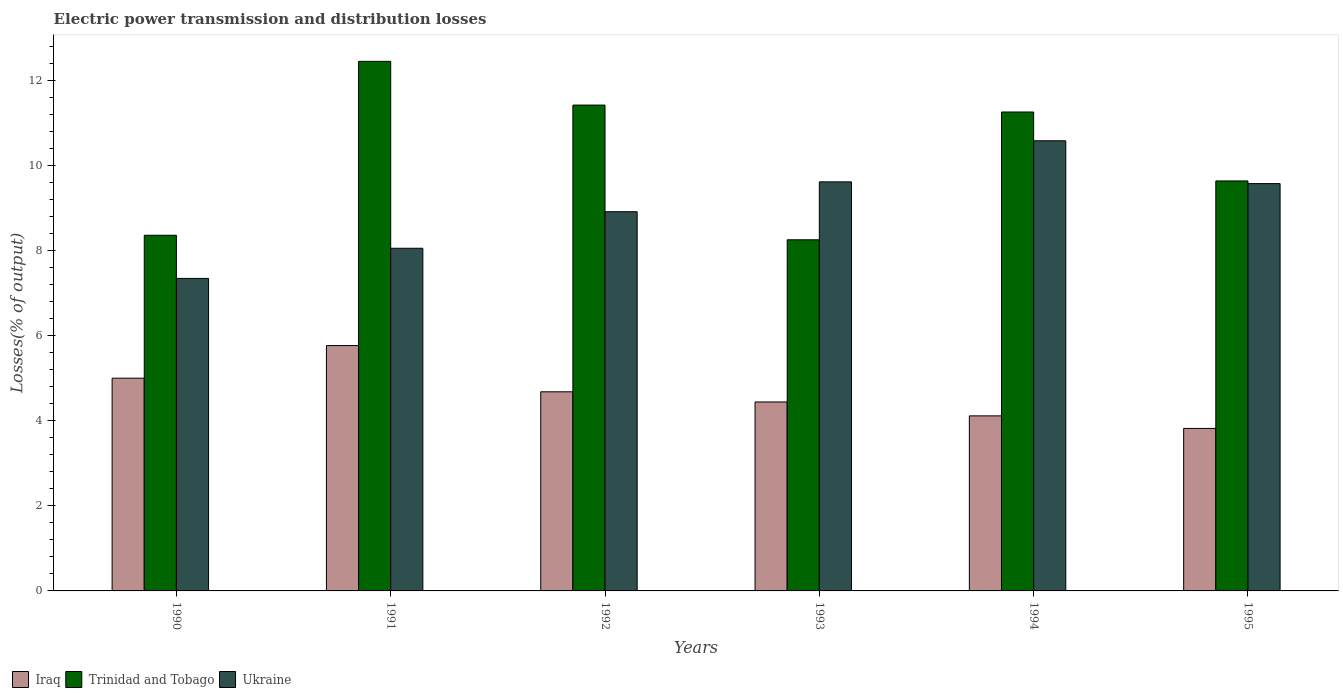How many different coloured bars are there?
Offer a terse response. 3. How many groups of bars are there?
Your response must be concise. 6. Are the number of bars per tick equal to the number of legend labels?
Ensure brevity in your answer.  Yes. How many bars are there on the 5th tick from the left?
Your answer should be very brief. 3. What is the label of the 5th group of bars from the left?
Give a very brief answer. 1994. In how many cases, is the number of bars for a given year not equal to the number of legend labels?
Offer a very short reply. 0. What is the electric power transmission and distribution losses in Ukraine in 1994?
Keep it short and to the point. 10.58. Across all years, what is the maximum electric power transmission and distribution losses in Ukraine?
Give a very brief answer. 10.58. Across all years, what is the minimum electric power transmission and distribution losses in Trinidad and Tobago?
Offer a terse response. 8.25. What is the total electric power transmission and distribution losses in Trinidad and Tobago in the graph?
Offer a very short reply. 61.37. What is the difference between the electric power transmission and distribution losses in Iraq in 1991 and that in 1993?
Make the answer very short. 1.33. What is the difference between the electric power transmission and distribution losses in Iraq in 1995 and the electric power transmission and distribution losses in Ukraine in 1990?
Provide a succinct answer. -3.52. What is the average electric power transmission and distribution losses in Trinidad and Tobago per year?
Offer a terse response. 10.23. In the year 1995, what is the difference between the electric power transmission and distribution losses in Iraq and electric power transmission and distribution losses in Trinidad and Tobago?
Offer a terse response. -5.82. What is the ratio of the electric power transmission and distribution losses in Trinidad and Tobago in 1991 to that in 1995?
Offer a terse response. 1.29. Is the electric power transmission and distribution losses in Iraq in 1994 less than that in 1995?
Provide a succinct answer. No. What is the difference between the highest and the second highest electric power transmission and distribution losses in Iraq?
Offer a terse response. 0.77. What is the difference between the highest and the lowest electric power transmission and distribution losses in Trinidad and Tobago?
Your answer should be very brief. 4.19. In how many years, is the electric power transmission and distribution losses in Trinidad and Tobago greater than the average electric power transmission and distribution losses in Trinidad and Tobago taken over all years?
Keep it short and to the point. 3. What does the 3rd bar from the left in 1993 represents?
Make the answer very short. Ukraine. What does the 3rd bar from the right in 1990 represents?
Provide a succinct answer. Iraq. Are all the bars in the graph horizontal?
Your response must be concise. No. Does the graph contain any zero values?
Give a very brief answer. No. Where does the legend appear in the graph?
Give a very brief answer. Bottom left. What is the title of the graph?
Offer a terse response. Electric power transmission and distribution losses. What is the label or title of the X-axis?
Give a very brief answer. Years. What is the label or title of the Y-axis?
Your answer should be compact. Losses(% of output). What is the Losses(% of output) of Iraq in 1990?
Provide a succinct answer. 5. What is the Losses(% of output) in Trinidad and Tobago in 1990?
Your response must be concise. 8.36. What is the Losses(% of output) in Ukraine in 1990?
Offer a terse response. 7.34. What is the Losses(% of output) in Iraq in 1991?
Keep it short and to the point. 5.77. What is the Losses(% of output) of Trinidad and Tobago in 1991?
Your answer should be compact. 12.45. What is the Losses(% of output) in Ukraine in 1991?
Keep it short and to the point. 8.05. What is the Losses(% of output) in Iraq in 1992?
Provide a succinct answer. 4.68. What is the Losses(% of output) of Trinidad and Tobago in 1992?
Ensure brevity in your answer.  11.42. What is the Losses(% of output) in Ukraine in 1992?
Your answer should be very brief. 8.91. What is the Losses(% of output) in Iraq in 1993?
Keep it short and to the point. 4.44. What is the Losses(% of output) of Trinidad and Tobago in 1993?
Make the answer very short. 8.25. What is the Losses(% of output) of Ukraine in 1993?
Your answer should be compact. 9.61. What is the Losses(% of output) of Iraq in 1994?
Make the answer very short. 4.11. What is the Losses(% of output) in Trinidad and Tobago in 1994?
Provide a succinct answer. 11.26. What is the Losses(% of output) in Ukraine in 1994?
Ensure brevity in your answer.  10.58. What is the Losses(% of output) of Iraq in 1995?
Offer a terse response. 3.82. What is the Losses(% of output) of Trinidad and Tobago in 1995?
Offer a very short reply. 9.64. What is the Losses(% of output) of Ukraine in 1995?
Your answer should be very brief. 9.57. Across all years, what is the maximum Losses(% of output) in Iraq?
Give a very brief answer. 5.77. Across all years, what is the maximum Losses(% of output) in Trinidad and Tobago?
Your answer should be very brief. 12.45. Across all years, what is the maximum Losses(% of output) in Ukraine?
Keep it short and to the point. 10.58. Across all years, what is the minimum Losses(% of output) in Iraq?
Ensure brevity in your answer.  3.82. Across all years, what is the minimum Losses(% of output) of Trinidad and Tobago?
Ensure brevity in your answer.  8.25. Across all years, what is the minimum Losses(% of output) in Ukraine?
Your response must be concise. 7.34. What is the total Losses(% of output) of Iraq in the graph?
Give a very brief answer. 27.82. What is the total Losses(% of output) of Trinidad and Tobago in the graph?
Ensure brevity in your answer.  61.37. What is the total Losses(% of output) in Ukraine in the graph?
Offer a terse response. 54.08. What is the difference between the Losses(% of output) in Iraq in 1990 and that in 1991?
Offer a terse response. -0.77. What is the difference between the Losses(% of output) of Trinidad and Tobago in 1990 and that in 1991?
Offer a very short reply. -4.09. What is the difference between the Losses(% of output) in Ukraine in 1990 and that in 1991?
Your answer should be compact. -0.71. What is the difference between the Losses(% of output) of Iraq in 1990 and that in 1992?
Your answer should be compact. 0.32. What is the difference between the Losses(% of output) in Trinidad and Tobago in 1990 and that in 1992?
Make the answer very short. -3.06. What is the difference between the Losses(% of output) in Ukraine in 1990 and that in 1992?
Your answer should be very brief. -1.57. What is the difference between the Losses(% of output) in Iraq in 1990 and that in 1993?
Keep it short and to the point. 0.56. What is the difference between the Losses(% of output) of Trinidad and Tobago in 1990 and that in 1993?
Make the answer very short. 0.11. What is the difference between the Losses(% of output) in Ukraine in 1990 and that in 1993?
Your response must be concise. -2.27. What is the difference between the Losses(% of output) in Iraq in 1990 and that in 1994?
Your answer should be very brief. 0.89. What is the difference between the Losses(% of output) of Trinidad and Tobago in 1990 and that in 1994?
Your answer should be very brief. -2.9. What is the difference between the Losses(% of output) of Ukraine in 1990 and that in 1994?
Make the answer very short. -3.24. What is the difference between the Losses(% of output) in Iraq in 1990 and that in 1995?
Make the answer very short. 1.18. What is the difference between the Losses(% of output) of Trinidad and Tobago in 1990 and that in 1995?
Make the answer very short. -1.28. What is the difference between the Losses(% of output) of Ukraine in 1990 and that in 1995?
Offer a very short reply. -2.23. What is the difference between the Losses(% of output) in Iraq in 1991 and that in 1992?
Offer a very short reply. 1.09. What is the difference between the Losses(% of output) of Trinidad and Tobago in 1991 and that in 1992?
Offer a terse response. 1.03. What is the difference between the Losses(% of output) in Ukraine in 1991 and that in 1992?
Keep it short and to the point. -0.86. What is the difference between the Losses(% of output) in Iraq in 1991 and that in 1993?
Provide a short and direct response. 1.33. What is the difference between the Losses(% of output) in Trinidad and Tobago in 1991 and that in 1993?
Keep it short and to the point. 4.19. What is the difference between the Losses(% of output) in Ukraine in 1991 and that in 1993?
Provide a succinct answer. -1.56. What is the difference between the Losses(% of output) of Iraq in 1991 and that in 1994?
Your answer should be very brief. 1.65. What is the difference between the Losses(% of output) in Trinidad and Tobago in 1991 and that in 1994?
Provide a succinct answer. 1.19. What is the difference between the Losses(% of output) of Ukraine in 1991 and that in 1994?
Ensure brevity in your answer.  -2.53. What is the difference between the Losses(% of output) of Iraq in 1991 and that in 1995?
Offer a terse response. 1.95. What is the difference between the Losses(% of output) of Trinidad and Tobago in 1991 and that in 1995?
Offer a terse response. 2.81. What is the difference between the Losses(% of output) of Ukraine in 1991 and that in 1995?
Make the answer very short. -1.52. What is the difference between the Losses(% of output) in Iraq in 1992 and that in 1993?
Give a very brief answer. 0.24. What is the difference between the Losses(% of output) of Trinidad and Tobago in 1992 and that in 1993?
Provide a short and direct response. 3.17. What is the difference between the Losses(% of output) in Ukraine in 1992 and that in 1993?
Give a very brief answer. -0.7. What is the difference between the Losses(% of output) of Iraq in 1992 and that in 1994?
Keep it short and to the point. 0.57. What is the difference between the Losses(% of output) of Trinidad and Tobago in 1992 and that in 1994?
Offer a very short reply. 0.16. What is the difference between the Losses(% of output) in Ukraine in 1992 and that in 1994?
Offer a very short reply. -1.67. What is the difference between the Losses(% of output) in Iraq in 1992 and that in 1995?
Keep it short and to the point. 0.86. What is the difference between the Losses(% of output) in Trinidad and Tobago in 1992 and that in 1995?
Ensure brevity in your answer.  1.78. What is the difference between the Losses(% of output) in Ukraine in 1992 and that in 1995?
Offer a terse response. -0.66. What is the difference between the Losses(% of output) in Iraq in 1993 and that in 1994?
Your answer should be very brief. 0.33. What is the difference between the Losses(% of output) of Trinidad and Tobago in 1993 and that in 1994?
Offer a terse response. -3. What is the difference between the Losses(% of output) of Ukraine in 1993 and that in 1994?
Make the answer very short. -0.97. What is the difference between the Losses(% of output) of Iraq in 1993 and that in 1995?
Make the answer very short. 0.62. What is the difference between the Losses(% of output) in Trinidad and Tobago in 1993 and that in 1995?
Offer a terse response. -1.38. What is the difference between the Losses(% of output) in Ukraine in 1993 and that in 1995?
Offer a very short reply. 0.04. What is the difference between the Losses(% of output) in Iraq in 1994 and that in 1995?
Your response must be concise. 0.29. What is the difference between the Losses(% of output) in Trinidad and Tobago in 1994 and that in 1995?
Your answer should be compact. 1.62. What is the difference between the Losses(% of output) in Iraq in 1990 and the Losses(% of output) in Trinidad and Tobago in 1991?
Your answer should be very brief. -7.45. What is the difference between the Losses(% of output) in Iraq in 1990 and the Losses(% of output) in Ukraine in 1991?
Your answer should be compact. -3.05. What is the difference between the Losses(% of output) of Trinidad and Tobago in 1990 and the Losses(% of output) of Ukraine in 1991?
Offer a very short reply. 0.31. What is the difference between the Losses(% of output) of Iraq in 1990 and the Losses(% of output) of Trinidad and Tobago in 1992?
Offer a terse response. -6.42. What is the difference between the Losses(% of output) of Iraq in 1990 and the Losses(% of output) of Ukraine in 1992?
Offer a terse response. -3.91. What is the difference between the Losses(% of output) of Trinidad and Tobago in 1990 and the Losses(% of output) of Ukraine in 1992?
Make the answer very short. -0.55. What is the difference between the Losses(% of output) of Iraq in 1990 and the Losses(% of output) of Trinidad and Tobago in 1993?
Your response must be concise. -3.25. What is the difference between the Losses(% of output) of Iraq in 1990 and the Losses(% of output) of Ukraine in 1993?
Provide a short and direct response. -4.61. What is the difference between the Losses(% of output) of Trinidad and Tobago in 1990 and the Losses(% of output) of Ukraine in 1993?
Offer a terse response. -1.25. What is the difference between the Losses(% of output) in Iraq in 1990 and the Losses(% of output) in Trinidad and Tobago in 1994?
Your answer should be compact. -6.26. What is the difference between the Losses(% of output) in Iraq in 1990 and the Losses(% of output) in Ukraine in 1994?
Offer a very short reply. -5.58. What is the difference between the Losses(% of output) in Trinidad and Tobago in 1990 and the Losses(% of output) in Ukraine in 1994?
Your answer should be compact. -2.22. What is the difference between the Losses(% of output) in Iraq in 1990 and the Losses(% of output) in Trinidad and Tobago in 1995?
Give a very brief answer. -4.64. What is the difference between the Losses(% of output) in Iraq in 1990 and the Losses(% of output) in Ukraine in 1995?
Make the answer very short. -4.57. What is the difference between the Losses(% of output) of Trinidad and Tobago in 1990 and the Losses(% of output) of Ukraine in 1995?
Offer a terse response. -1.21. What is the difference between the Losses(% of output) in Iraq in 1991 and the Losses(% of output) in Trinidad and Tobago in 1992?
Make the answer very short. -5.65. What is the difference between the Losses(% of output) in Iraq in 1991 and the Losses(% of output) in Ukraine in 1992?
Give a very brief answer. -3.15. What is the difference between the Losses(% of output) in Trinidad and Tobago in 1991 and the Losses(% of output) in Ukraine in 1992?
Keep it short and to the point. 3.53. What is the difference between the Losses(% of output) in Iraq in 1991 and the Losses(% of output) in Trinidad and Tobago in 1993?
Provide a short and direct response. -2.49. What is the difference between the Losses(% of output) of Iraq in 1991 and the Losses(% of output) of Ukraine in 1993?
Offer a very short reply. -3.85. What is the difference between the Losses(% of output) of Trinidad and Tobago in 1991 and the Losses(% of output) of Ukraine in 1993?
Ensure brevity in your answer.  2.83. What is the difference between the Losses(% of output) in Iraq in 1991 and the Losses(% of output) in Trinidad and Tobago in 1994?
Ensure brevity in your answer.  -5.49. What is the difference between the Losses(% of output) in Iraq in 1991 and the Losses(% of output) in Ukraine in 1994?
Your response must be concise. -4.81. What is the difference between the Losses(% of output) of Trinidad and Tobago in 1991 and the Losses(% of output) of Ukraine in 1994?
Keep it short and to the point. 1.87. What is the difference between the Losses(% of output) in Iraq in 1991 and the Losses(% of output) in Trinidad and Tobago in 1995?
Give a very brief answer. -3.87. What is the difference between the Losses(% of output) of Iraq in 1991 and the Losses(% of output) of Ukraine in 1995?
Ensure brevity in your answer.  -3.81. What is the difference between the Losses(% of output) of Trinidad and Tobago in 1991 and the Losses(% of output) of Ukraine in 1995?
Make the answer very short. 2.87. What is the difference between the Losses(% of output) of Iraq in 1992 and the Losses(% of output) of Trinidad and Tobago in 1993?
Keep it short and to the point. -3.57. What is the difference between the Losses(% of output) of Iraq in 1992 and the Losses(% of output) of Ukraine in 1993?
Give a very brief answer. -4.93. What is the difference between the Losses(% of output) of Trinidad and Tobago in 1992 and the Losses(% of output) of Ukraine in 1993?
Ensure brevity in your answer.  1.8. What is the difference between the Losses(% of output) of Iraq in 1992 and the Losses(% of output) of Trinidad and Tobago in 1994?
Your answer should be very brief. -6.58. What is the difference between the Losses(% of output) of Iraq in 1992 and the Losses(% of output) of Ukraine in 1994?
Your answer should be compact. -5.9. What is the difference between the Losses(% of output) of Trinidad and Tobago in 1992 and the Losses(% of output) of Ukraine in 1994?
Keep it short and to the point. 0.84. What is the difference between the Losses(% of output) in Iraq in 1992 and the Losses(% of output) in Trinidad and Tobago in 1995?
Provide a succinct answer. -4.96. What is the difference between the Losses(% of output) in Iraq in 1992 and the Losses(% of output) in Ukraine in 1995?
Offer a very short reply. -4.89. What is the difference between the Losses(% of output) of Trinidad and Tobago in 1992 and the Losses(% of output) of Ukraine in 1995?
Your answer should be compact. 1.85. What is the difference between the Losses(% of output) of Iraq in 1993 and the Losses(% of output) of Trinidad and Tobago in 1994?
Your answer should be very brief. -6.81. What is the difference between the Losses(% of output) of Iraq in 1993 and the Losses(% of output) of Ukraine in 1994?
Offer a very short reply. -6.14. What is the difference between the Losses(% of output) in Trinidad and Tobago in 1993 and the Losses(% of output) in Ukraine in 1994?
Keep it short and to the point. -2.33. What is the difference between the Losses(% of output) of Iraq in 1993 and the Losses(% of output) of Trinidad and Tobago in 1995?
Your response must be concise. -5.19. What is the difference between the Losses(% of output) in Iraq in 1993 and the Losses(% of output) in Ukraine in 1995?
Give a very brief answer. -5.13. What is the difference between the Losses(% of output) of Trinidad and Tobago in 1993 and the Losses(% of output) of Ukraine in 1995?
Your response must be concise. -1.32. What is the difference between the Losses(% of output) in Iraq in 1994 and the Losses(% of output) in Trinidad and Tobago in 1995?
Offer a terse response. -5.52. What is the difference between the Losses(% of output) of Iraq in 1994 and the Losses(% of output) of Ukraine in 1995?
Provide a succinct answer. -5.46. What is the difference between the Losses(% of output) in Trinidad and Tobago in 1994 and the Losses(% of output) in Ukraine in 1995?
Make the answer very short. 1.68. What is the average Losses(% of output) of Iraq per year?
Provide a short and direct response. 4.64. What is the average Losses(% of output) in Trinidad and Tobago per year?
Offer a terse response. 10.23. What is the average Losses(% of output) of Ukraine per year?
Give a very brief answer. 9.01. In the year 1990, what is the difference between the Losses(% of output) of Iraq and Losses(% of output) of Trinidad and Tobago?
Give a very brief answer. -3.36. In the year 1990, what is the difference between the Losses(% of output) in Iraq and Losses(% of output) in Ukraine?
Your answer should be compact. -2.34. In the year 1990, what is the difference between the Losses(% of output) of Trinidad and Tobago and Losses(% of output) of Ukraine?
Offer a terse response. 1.01. In the year 1991, what is the difference between the Losses(% of output) in Iraq and Losses(% of output) in Trinidad and Tobago?
Your answer should be very brief. -6.68. In the year 1991, what is the difference between the Losses(% of output) of Iraq and Losses(% of output) of Ukraine?
Give a very brief answer. -2.29. In the year 1991, what is the difference between the Losses(% of output) in Trinidad and Tobago and Losses(% of output) in Ukraine?
Make the answer very short. 4.39. In the year 1992, what is the difference between the Losses(% of output) in Iraq and Losses(% of output) in Trinidad and Tobago?
Provide a short and direct response. -6.74. In the year 1992, what is the difference between the Losses(% of output) of Iraq and Losses(% of output) of Ukraine?
Provide a succinct answer. -4.23. In the year 1992, what is the difference between the Losses(% of output) of Trinidad and Tobago and Losses(% of output) of Ukraine?
Your answer should be very brief. 2.51. In the year 1993, what is the difference between the Losses(% of output) in Iraq and Losses(% of output) in Trinidad and Tobago?
Your answer should be compact. -3.81. In the year 1993, what is the difference between the Losses(% of output) in Iraq and Losses(% of output) in Ukraine?
Keep it short and to the point. -5.17. In the year 1993, what is the difference between the Losses(% of output) of Trinidad and Tobago and Losses(% of output) of Ukraine?
Ensure brevity in your answer.  -1.36. In the year 1994, what is the difference between the Losses(% of output) of Iraq and Losses(% of output) of Trinidad and Tobago?
Make the answer very short. -7.14. In the year 1994, what is the difference between the Losses(% of output) of Iraq and Losses(% of output) of Ukraine?
Offer a terse response. -6.47. In the year 1994, what is the difference between the Losses(% of output) in Trinidad and Tobago and Losses(% of output) in Ukraine?
Your answer should be very brief. 0.68. In the year 1995, what is the difference between the Losses(% of output) of Iraq and Losses(% of output) of Trinidad and Tobago?
Your response must be concise. -5.82. In the year 1995, what is the difference between the Losses(% of output) of Iraq and Losses(% of output) of Ukraine?
Ensure brevity in your answer.  -5.75. In the year 1995, what is the difference between the Losses(% of output) in Trinidad and Tobago and Losses(% of output) in Ukraine?
Provide a short and direct response. 0.06. What is the ratio of the Losses(% of output) of Iraq in 1990 to that in 1991?
Offer a terse response. 0.87. What is the ratio of the Losses(% of output) in Trinidad and Tobago in 1990 to that in 1991?
Give a very brief answer. 0.67. What is the ratio of the Losses(% of output) in Ukraine in 1990 to that in 1991?
Your response must be concise. 0.91. What is the ratio of the Losses(% of output) of Iraq in 1990 to that in 1992?
Give a very brief answer. 1.07. What is the ratio of the Losses(% of output) in Trinidad and Tobago in 1990 to that in 1992?
Provide a succinct answer. 0.73. What is the ratio of the Losses(% of output) in Ukraine in 1990 to that in 1992?
Ensure brevity in your answer.  0.82. What is the ratio of the Losses(% of output) of Iraq in 1990 to that in 1993?
Offer a very short reply. 1.13. What is the ratio of the Losses(% of output) of Trinidad and Tobago in 1990 to that in 1993?
Provide a succinct answer. 1.01. What is the ratio of the Losses(% of output) of Ukraine in 1990 to that in 1993?
Your answer should be compact. 0.76. What is the ratio of the Losses(% of output) of Iraq in 1990 to that in 1994?
Ensure brevity in your answer.  1.22. What is the ratio of the Losses(% of output) of Trinidad and Tobago in 1990 to that in 1994?
Offer a terse response. 0.74. What is the ratio of the Losses(% of output) in Ukraine in 1990 to that in 1994?
Provide a succinct answer. 0.69. What is the ratio of the Losses(% of output) in Iraq in 1990 to that in 1995?
Make the answer very short. 1.31. What is the ratio of the Losses(% of output) of Trinidad and Tobago in 1990 to that in 1995?
Your response must be concise. 0.87. What is the ratio of the Losses(% of output) of Ukraine in 1990 to that in 1995?
Keep it short and to the point. 0.77. What is the ratio of the Losses(% of output) in Iraq in 1991 to that in 1992?
Your response must be concise. 1.23. What is the ratio of the Losses(% of output) in Trinidad and Tobago in 1991 to that in 1992?
Give a very brief answer. 1.09. What is the ratio of the Losses(% of output) of Ukraine in 1991 to that in 1992?
Your response must be concise. 0.9. What is the ratio of the Losses(% of output) in Iraq in 1991 to that in 1993?
Your response must be concise. 1.3. What is the ratio of the Losses(% of output) of Trinidad and Tobago in 1991 to that in 1993?
Offer a very short reply. 1.51. What is the ratio of the Losses(% of output) in Ukraine in 1991 to that in 1993?
Your answer should be compact. 0.84. What is the ratio of the Losses(% of output) in Iraq in 1991 to that in 1994?
Ensure brevity in your answer.  1.4. What is the ratio of the Losses(% of output) in Trinidad and Tobago in 1991 to that in 1994?
Give a very brief answer. 1.11. What is the ratio of the Losses(% of output) of Ukraine in 1991 to that in 1994?
Offer a terse response. 0.76. What is the ratio of the Losses(% of output) in Iraq in 1991 to that in 1995?
Your response must be concise. 1.51. What is the ratio of the Losses(% of output) in Trinidad and Tobago in 1991 to that in 1995?
Your answer should be compact. 1.29. What is the ratio of the Losses(% of output) of Ukraine in 1991 to that in 1995?
Ensure brevity in your answer.  0.84. What is the ratio of the Losses(% of output) in Iraq in 1992 to that in 1993?
Your answer should be compact. 1.05. What is the ratio of the Losses(% of output) in Trinidad and Tobago in 1992 to that in 1993?
Keep it short and to the point. 1.38. What is the ratio of the Losses(% of output) in Ukraine in 1992 to that in 1993?
Your response must be concise. 0.93. What is the ratio of the Losses(% of output) of Iraq in 1992 to that in 1994?
Give a very brief answer. 1.14. What is the ratio of the Losses(% of output) in Trinidad and Tobago in 1992 to that in 1994?
Provide a succinct answer. 1.01. What is the ratio of the Losses(% of output) in Ukraine in 1992 to that in 1994?
Keep it short and to the point. 0.84. What is the ratio of the Losses(% of output) in Iraq in 1992 to that in 1995?
Keep it short and to the point. 1.23. What is the ratio of the Losses(% of output) in Trinidad and Tobago in 1992 to that in 1995?
Offer a very short reply. 1.19. What is the ratio of the Losses(% of output) in Ukraine in 1992 to that in 1995?
Ensure brevity in your answer.  0.93. What is the ratio of the Losses(% of output) in Iraq in 1993 to that in 1994?
Give a very brief answer. 1.08. What is the ratio of the Losses(% of output) of Trinidad and Tobago in 1993 to that in 1994?
Offer a very short reply. 0.73. What is the ratio of the Losses(% of output) in Ukraine in 1993 to that in 1994?
Your answer should be very brief. 0.91. What is the ratio of the Losses(% of output) of Iraq in 1993 to that in 1995?
Provide a succinct answer. 1.16. What is the ratio of the Losses(% of output) in Trinidad and Tobago in 1993 to that in 1995?
Keep it short and to the point. 0.86. What is the ratio of the Losses(% of output) in Ukraine in 1993 to that in 1995?
Provide a succinct answer. 1. What is the ratio of the Losses(% of output) in Iraq in 1994 to that in 1995?
Offer a terse response. 1.08. What is the ratio of the Losses(% of output) in Trinidad and Tobago in 1994 to that in 1995?
Offer a terse response. 1.17. What is the ratio of the Losses(% of output) of Ukraine in 1994 to that in 1995?
Offer a very short reply. 1.11. What is the difference between the highest and the second highest Losses(% of output) in Iraq?
Make the answer very short. 0.77. What is the difference between the highest and the second highest Losses(% of output) in Trinidad and Tobago?
Your response must be concise. 1.03. What is the difference between the highest and the second highest Losses(% of output) of Ukraine?
Your answer should be very brief. 0.97. What is the difference between the highest and the lowest Losses(% of output) in Iraq?
Make the answer very short. 1.95. What is the difference between the highest and the lowest Losses(% of output) in Trinidad and Tobago?
Your answer should be very brief. 4.19. What is the difference between the highest and the lowest Losses(% of output) in Ukraine?
Provide a short and direct response. 3.24. 